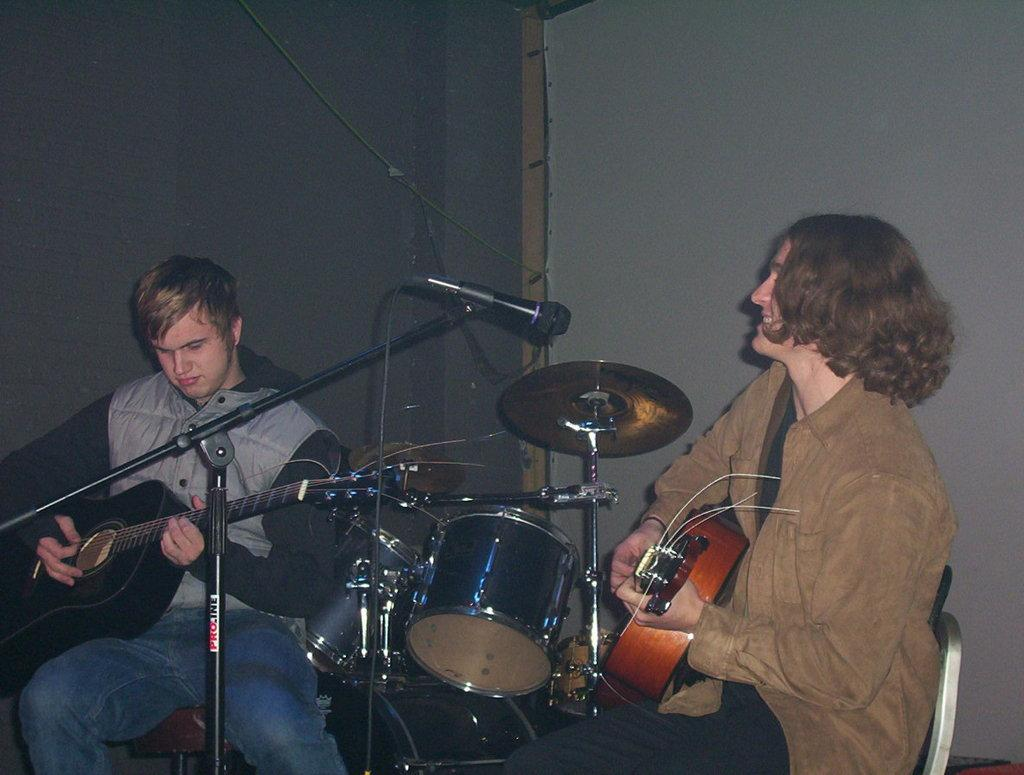How many people are in the image? There are two persons in the image. What are the persons doing in the image? The persons are sitting on chairs and playing guitars. What are the persons wearing in the image? The persons are wearing jackets. What else can be seen in front of the persons? There are musical instruments in front of them. What might be used for amplifying their voices in the image? There is a mic with a holder in the image. What type of space-related riddle can be seen on the writer's desk in the image? There is no writer or desk present in the image, and therefore no riddle can be seen. 